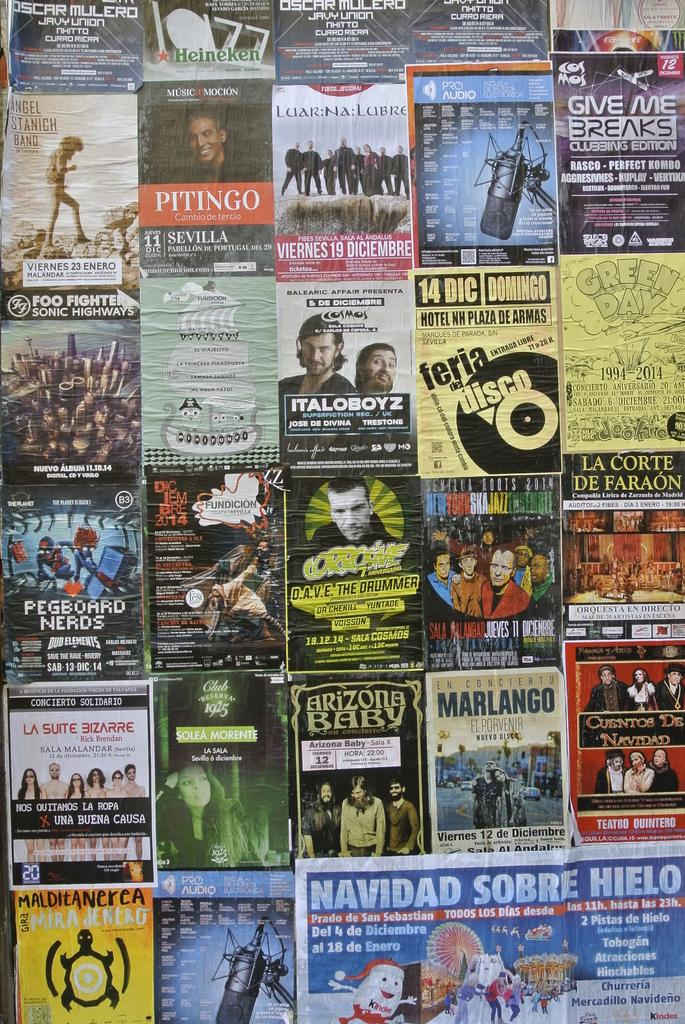<image>
Present a compact description of the photo's key features. Marlango nuevo disco paper, Pegboard Nerds paper, and give me breaks paper posted on a wall 